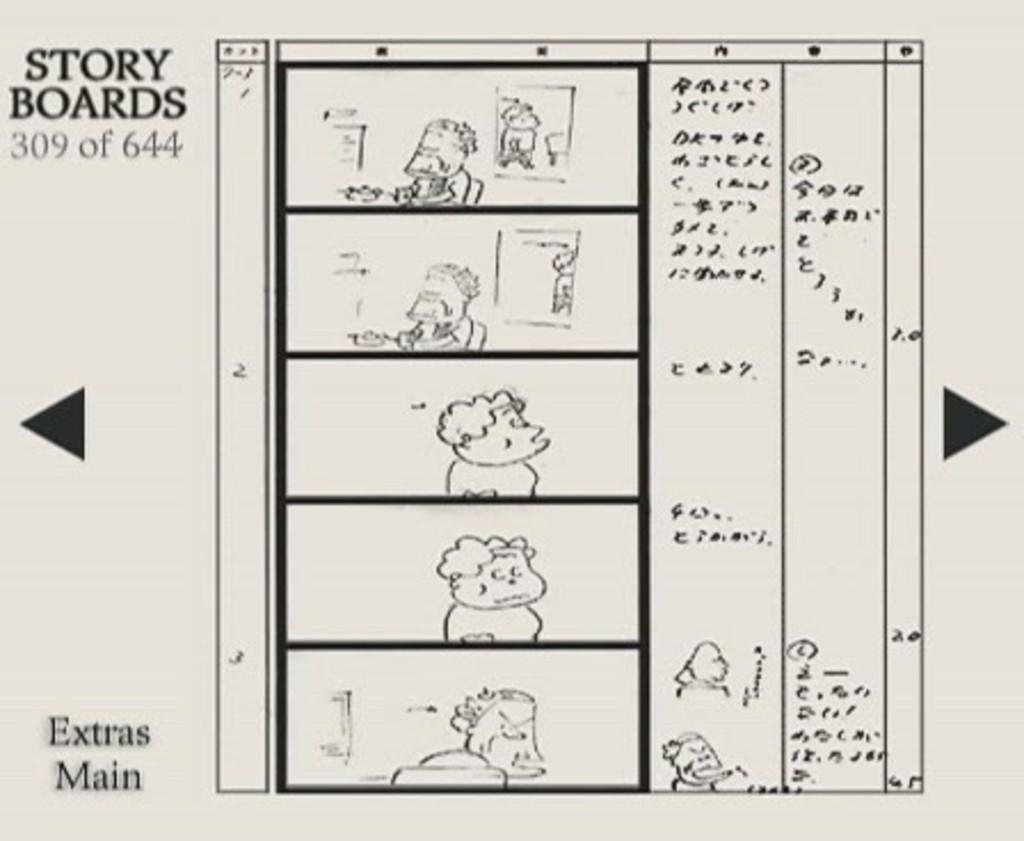Describe this image in one or two sentences. In this picture there is a white paper on which some cartoons are drawn. On the left side there is a small quotes written on it. 